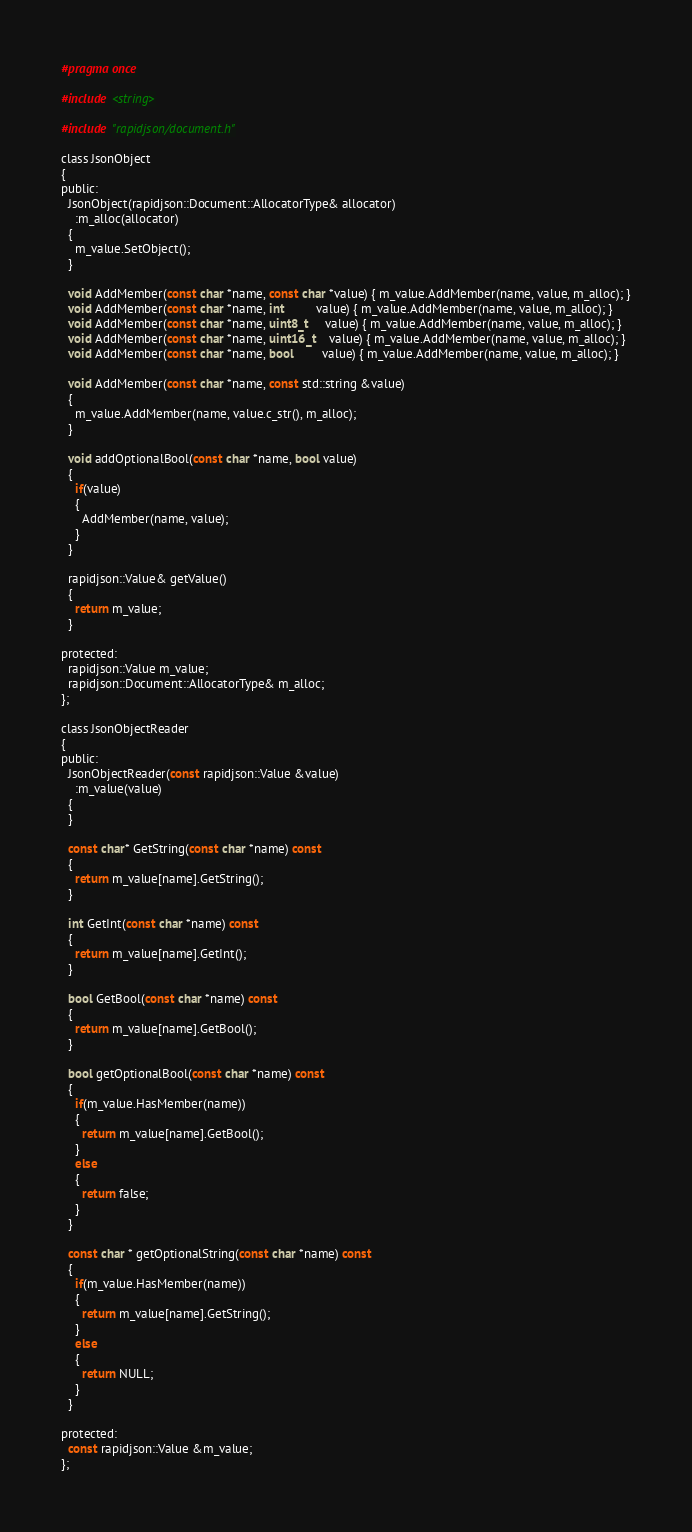<code> <loc_0><loc_0><loc_500><loc_500><_C_>#pragma once

#include <string>

#include "rapidjson/document.h"

class JsonObject
{
public:
  JsonObject(rapidjson::Document::AllocatorType& allocator)
    :m_alloc(allocator)
  {
    m_value.SetObject();
  }

  void AddMember(const char *name, const char *value) { m_value.AddMember(name, value, m_alloc); }
  void AddMember(const char *name, int         value) { m_value.AddMember(name, value, m_alloc); }
  void AddMember(const char *name, uint8_t     value) { m_value.AddMember(name, value, m_alloc); }
  void AddMember(const char *name, uint16_t    value) { m_value.AddMember(name, value, m_alloc); }
  void AddMember(const char *name, bool        value) { m_value.AddMember(name, value, m_alloc); }

  void AddMember(const char *name, const std::string &value)
  {
    m_value.AddMember(name, value.c_str(), m_alloc);
  }

  void addOptionalBool(const char *name, bool value)
  {
    if(value)
    {
      AddMember(name, value);
    }
  }

  rapidjson::Value& getValue()
  {
    return m_value;
  }

protected:
  rapidjson::Value m_value;
  rapidjson::Document::AllocatorType& m_alloc;
};

class JsonObjectReader
{
public:
  JsonObjectReader(const rapidjson::Value &value)
    :m_value(value)
  {
  }

  const char* GetString(const char *name) const
  {
    return m_value[name].GetString();
  }

  int GetInt(const char *name) const
  {
    return m_value[name].GetInt();
  }

  bool GetBool(const char *name) const
  {
    return m_value[name].GetBool();
  }

  bool getOptionalBool(const char *name) const
  {
    if(m_value.HasMember(name))
    {
      return m_value[name].GetBool();
    }
    else
    {
      return false;
    }
  }

  const char * getOptionalString(const char *name) const
  {
    if(m_value.HasMember(name))
    {
      return m_value[name].GetString();
    }
    else
    {
      return NULL;
    }
  }

protected:
  const rapidjson::Value &m_value;
};
</code> 